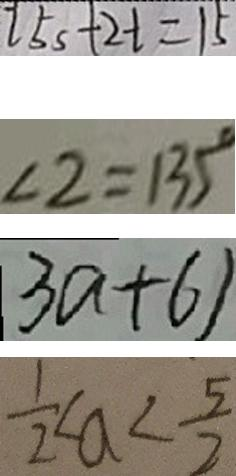<formula> <loc_0><loc_0><loc_500><loc_500>2 5 s + 2 t = 1 5 
 \angle 2 = 1 3 5 ^ { \circ } 
 3 a + 6 ) 
 \frac { 1 } { 2 } < a < \frac { 5 } { 2 }</formula> 